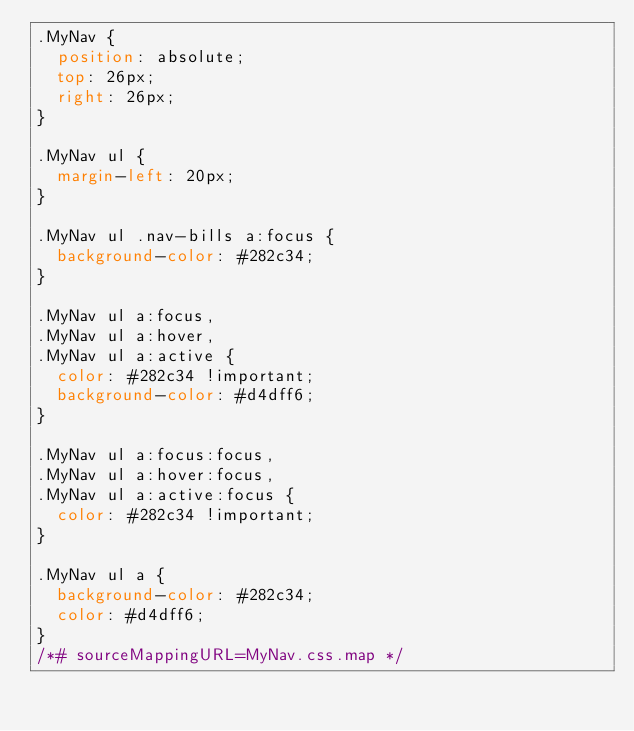<code> <loc_0><loc_0><loc_500><loc_500><_CSS_>.MyNav {
  position: absolute;
  top: 26px;
  right: 26px;
}

.MyNav ul {
  margin-left: 20px;
}

.MyNav ul .nav-bills a:focus {
  background-color: #282c34;
}

.MyNav ul a:focus,
.MyNav ul a:hover,
.MyNav ul a:active {
  color: #282c34 !important;
  background-color: #d4dff6;
}

.MyNav ul a:focus:focus,
.MyNav ul a:hover:focus,
.MyNav ul a:active:focus {
  color: #282c34 !important;
}

.MyNav ul a {
  background-color: #282c34;
  color: #d4dff6;
}
/*# sourceMappingURL=MyNav.css.map */</code> 